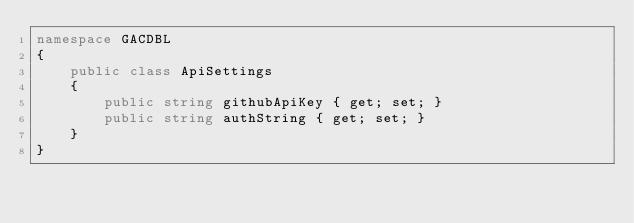<code> <loc_0><loc_0><loc_500><loc_500><_C#_>namespace GACDBL
{
    public class ApiSettings
    {
        public string githubApiKey { get; set; }
        public string authString { get; set; }
    }
}</code> 